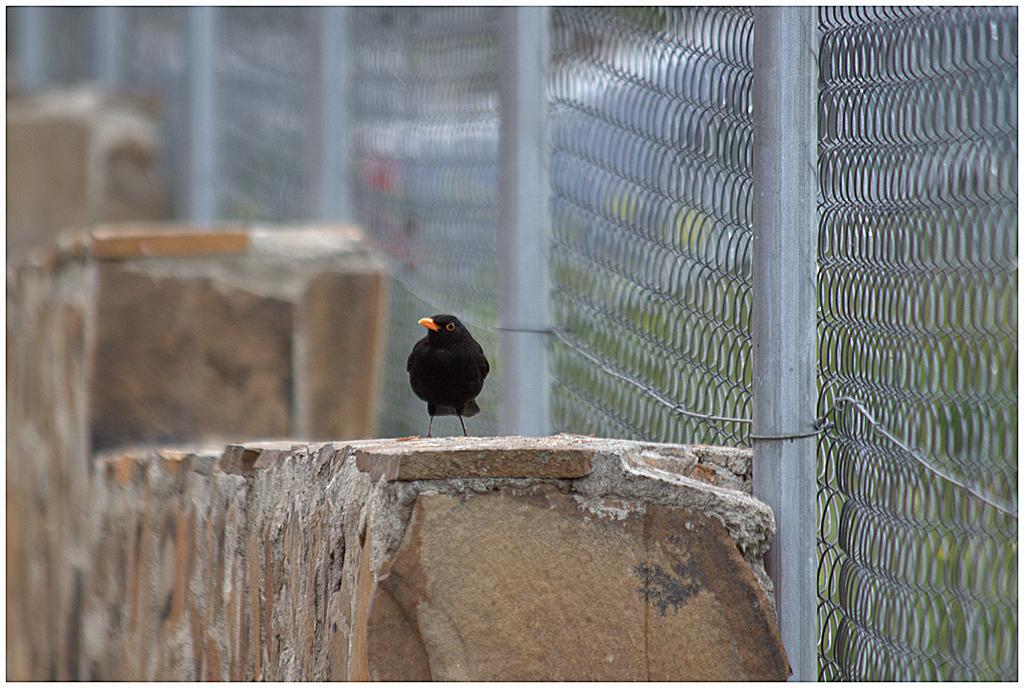What is the main subject in the center of the image? There is a bird on the wall in the center of the image. What is located at the bottom of the image? There is a wall at the bottom of the image. What can be seen on the right side of the image? There is a net and poles on the right side of the image. How many minutes does the bird have in the image? There is no mention of time or minutes in the image, so it is not possible to determine how many minutes the bird has. 